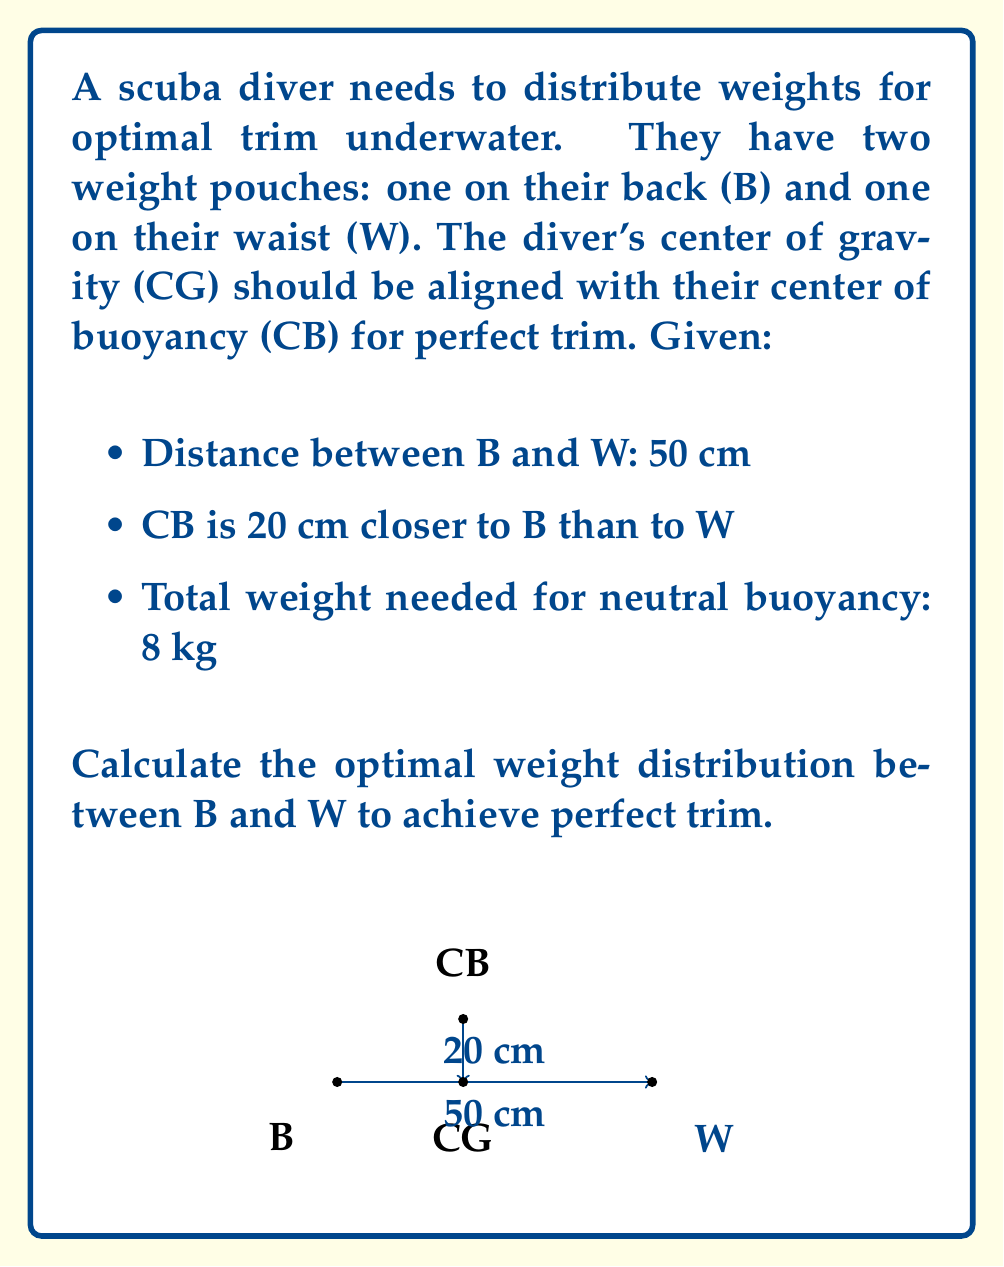Help me with this question. To solve this problem, we'll use the principle of moments and the given information:

1. Let $x$ be the weight in the back pouch (B) and $(8-x)$ be the weight in the waist pouch (W).

2. The center of gravity (CG) should align with the center of buoyancy (CB). CB is 20 cm closer to B, so it's located at 30 cm from W and 20 cm from B.

3. Using the principle of moments around CB:
   $$ x \cdot 20 = (8-x) \cdot 30 $$

4. Expand the equation:
   $$ 20x = 240 - 30x $$

5. Combine like terms:
   $$ 50x = 240 $$

6. Solve for x:
   $$ x = \frac{240}{50} = 4.8 $$

7. The weight in the back pouch (B) is 4.8 kg, so the weight in the waist pouch (W) is:
   $$ 8 - 4.8 = 3.2 \text{ kg} $$

Therefore, the optimal weight distribution is 4.8 kg in the back pouch and 3.2 kg in the waist pouch.
Answer: Back pouch: 4.8 kg, Waist pouch: 3.2 kg 